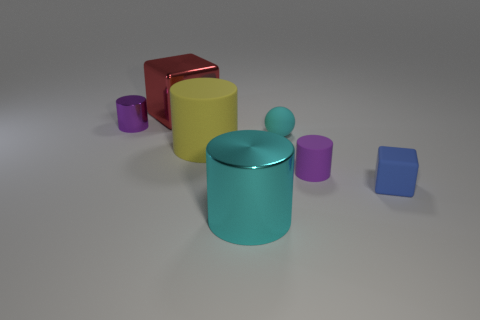Subtract 1 cylinders. How many cylinders are left? 3 Add 1 big red metal things. How many objects exist? 8 Subtract all cylinders. How many objects are left? 3 Subtract all large red metal cubes. Subtract all yellow matte cylinders. How many objects are left? 5 Add 3 large yellow matte cylinders. How many large yellow matte cylinders are left? 4 Add 6 large cyan shiny cylinders. How many large cyan shiny cylinders exist? 7 Subtract 2 purple cylinders. How many objects are left? 5 